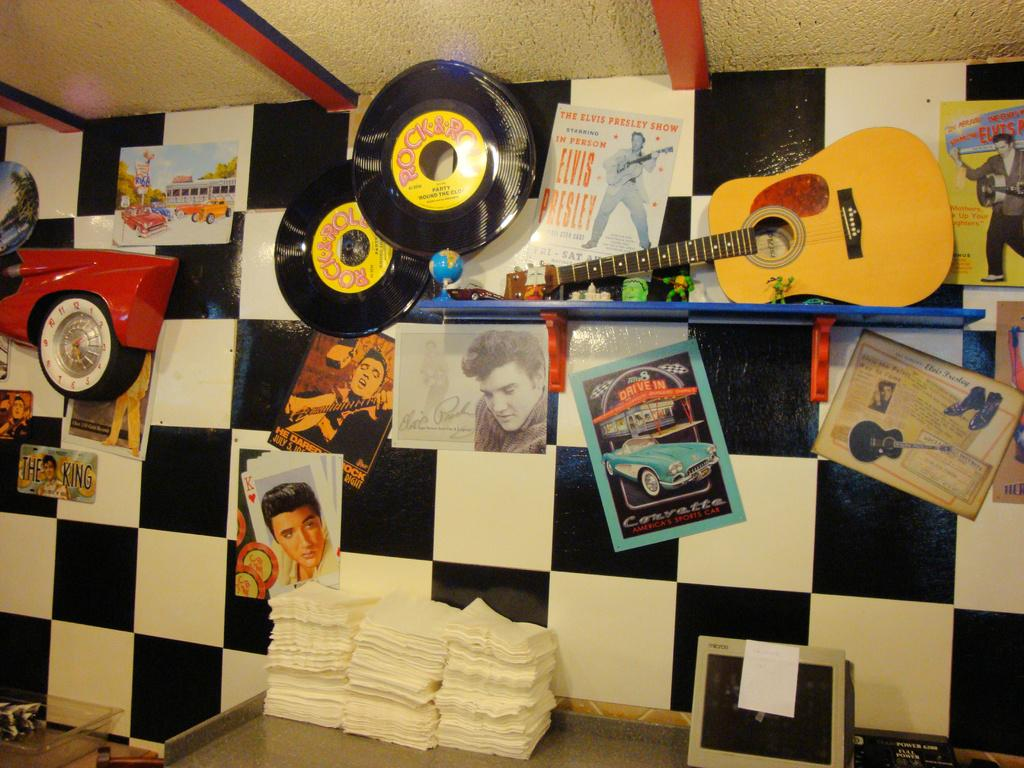What type of items can be seen in the image? There are photos, a guitar, and 2 CDs in the image. Where are the CDs and guitar located in the image? The CDs and guitar are on the wall in the image. What is present on the table in the image? There are tissues on the table in the image. How does the organization of the photos in the image compare to the organization of the earth's continents? The organization of the photos in the image cannot be compared to the organization of the earth's continents, as they are unrelated subjects. 